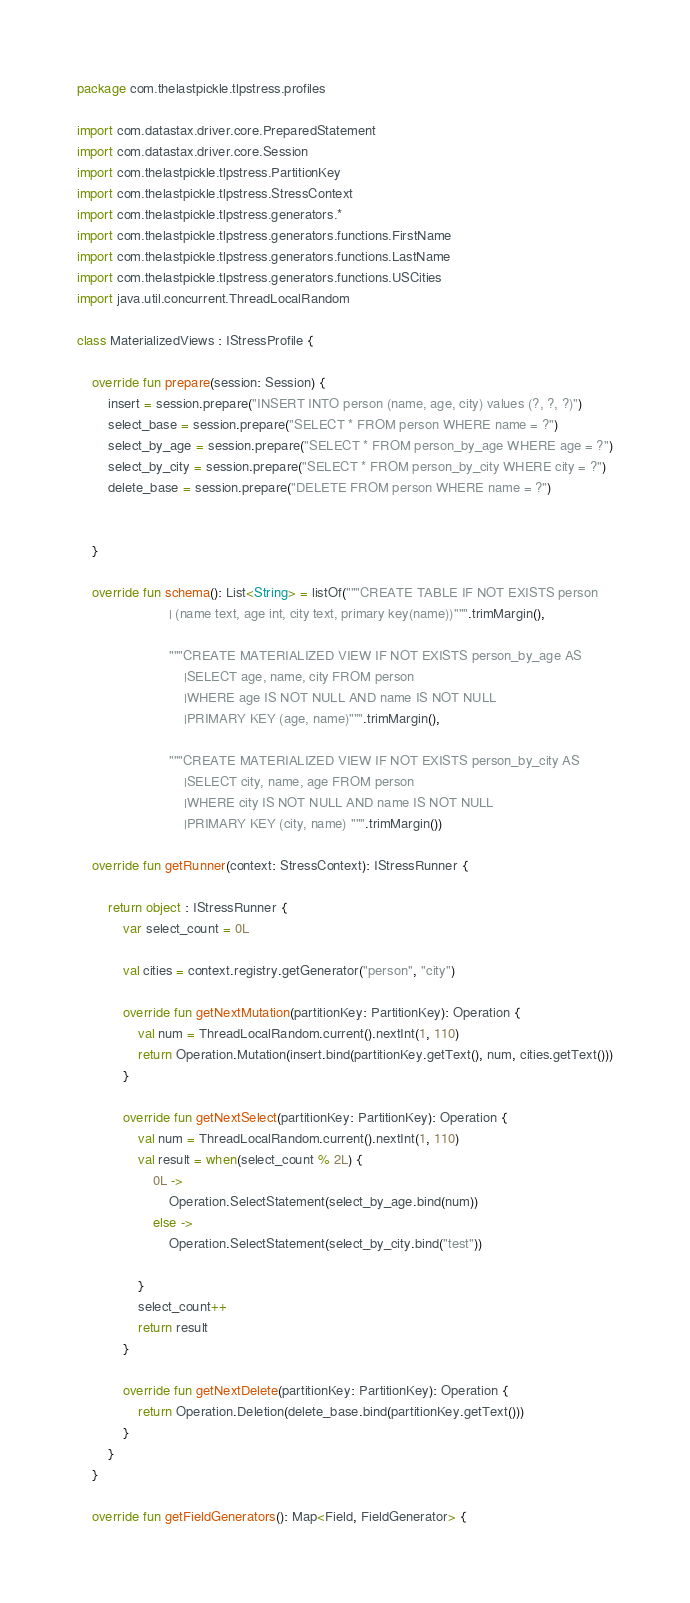<code> <loc_0><loc_0><loc_500><loc_500><_Kotlin_>package com.thelastpickle.tlpstress.profiles

import com.datastax.driver.core.PreparedStatement
import com.datastax.driver.core.Session
import com.thelastpickle.tlpstress.PartitionKey
import com.thelastpickle.tlpstress.StressContext
import com.thelastpickle.tlpstress.generators.*
import com.thelastpickle.tlpstress.generators.functions.FirstName
import com.thelastpickle.tlpstress.generators.functions.LastName
import com.thelastpickle.tlpstress.generators.functions.USCities
import java.util.concurrent.ThreadLocalRandom

class MaterializedViews : IStressProfile {

    override fun prepare(session: Session) {
        insert = session.prepare("INSERT INTO person (name, age, city) values (?, ?, ?)")
        select_base = session.prepare("SELECT * FROM person WHERE name = ?")
        select_by_age = session.prepare("SELECT * FROM person_by_age WHERE age = ?")
        select_by_city = session.prepare("SELECT * FROM person_by_city WHERE city = ?")
        delete_base = session.prepare("DELETE FROM person WHERE name = ?")


    }

    override fun schema(): List<String> = listOf("""CREATE TABLE IF NOT EXISTS person
                        | (name text, age int, city text, primary key(name))""".trimMargin(),

                        """CREATE MATERIALIZED VIEW IF NOT EXISTS person_by_age AS
                            |SELECT age, name, city FROM person
                            |WHERE age IS NOT NULL AND name IS NOT NULL
                            |PRIMARY KEY (age, name)""".trimMargin(),

                        """CREATE MATERIALIZED VIEW IF NOT EXISTS person_by_city AS
                            |SELECT city, name, age FROM person
                            |WHERE city IS NOT NULL AND name IS NOT NULL
                            |PRIMARY KEY (city, name) """.trimMargin())

    override fun getRunner(context: StressContext): IStressRunner {

        return object : IStressRunner {
            var select_count = 0L

            val cities = context.registry.getGenerator("person", "city")

            override fun getNextMutation(partitionKey: PartitionKey): Operation {
                val num = ThreadLocalRandom.current().nextInt(1, 110)
                return Operation.Mutation(insert.bind(partitionKey.getText(), num, cities.getText()))
            }

            override fun getNextSelect(partitionKey: PartitionKey): Operation {
                val num = ThreadLocalRandom.current().nextInt(1, 110)
                val result = when(select_count % 2L) {
                    0L ->
                        Operation.SelectStatement(select_by_age.bind(num))
                    else ->
                        Operation.SelectStatement(select_by_city.bind("test"))

                }
                select_count++
                return result
            }

            override fun getNextDelete(partitionKey: PartitionKey): Operation {
                return Operation.Deletion(delete_base.bind(partitionKey.getText()))
            }
        }
    }

    override fun getFieldGenerators(): Map<Field, FieldGenerator> {</code> 